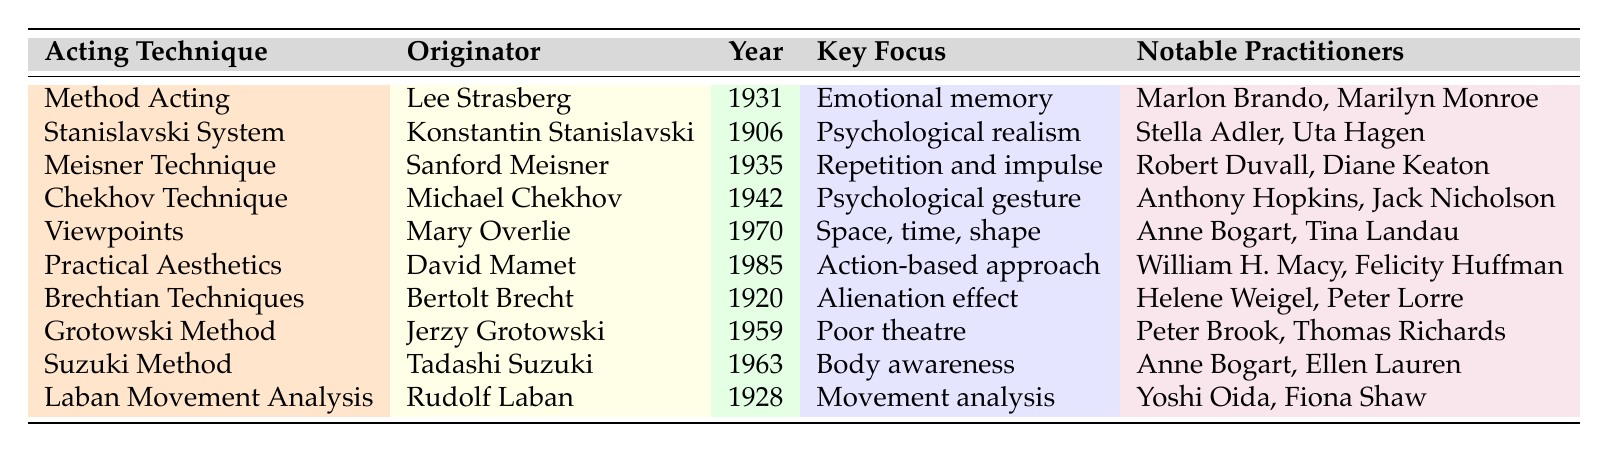What is the originator of Method Acting? The table lists "Method Acting" in the first row and shows that Lee Strasberg is the originator next to it.
Answer: Lee Strasberg Which acting technique was developed in 1906? Scanning the second row of the table, I find that the "Stanislavski System" was developed in 1906.
Answer: Stanislavski System How many acting techniques were developed in the 20th century? By checking the "Year Developed" column, we count the techniques: Stanislavski System (1906), Brechtian Techniques (1920), Laban Movement Analysis (1928), Method Acting (1931), Meisner Technique (1935), Chekhov Technique (1942), Grotowski Method (1959), Suzuki Method (1963), and Practical Aesthetics (1985). This gives us a total of 9 techniques developed in the 20th century.
Answer: 9 What is the key focus of the Laban Movement Analysis? Looking at the last row of the table, I see that the key focus for Laban Movement Analysis is "Movement analysis."
Answer: Movement analysis Who were the notable practitioners of the Chekhov Technique? The table shows in the row for the Chekhov Technique that notable practitioners are "Anthony Hopkins" and "Jack Nicholson."
Answer: Anthony Hopkins, Jack Nicholson Is there a technique focused on emotional memory? The first row indicates that Method Acting has a key focus on emotional memory. Therefore, the answer is yes.
Answer: Yes What is the earliest acting technique listed in the table? Reviewing the "Year Developed" column, the earliest date is 1906 for the Stanislavski System, which is the first technique developed listed in the table.
Answer: Stanislavski System What is the average year of development for the acting techniques listed? Adding the years together: (1931 + 1906 + 1935 + 1942 + 1970 + 1985 + 1920 + 1959 + 1963 + 1928) = 19,929. Dividing by 10 shows the average is 1,992.9, rounding gives the average year developed as approximately 1950.
Answer: 1950 Which acting technique has a key focus on an action-based approach? Searching the table reveals that Practical Aesthetics, listed under its key focus, emphasizes an action-based approach.
Answer: Practical Aesthetics Which originator is associated with Brechtian Techniques? The table shows that Bertolt Brecht is the originator of the technique, listed in the row for Brechtian Techniques.
Answer: Bertolt Brecht 